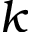<formula> <loc_0><loc_0><loc_500><loc_500>k</formula> 